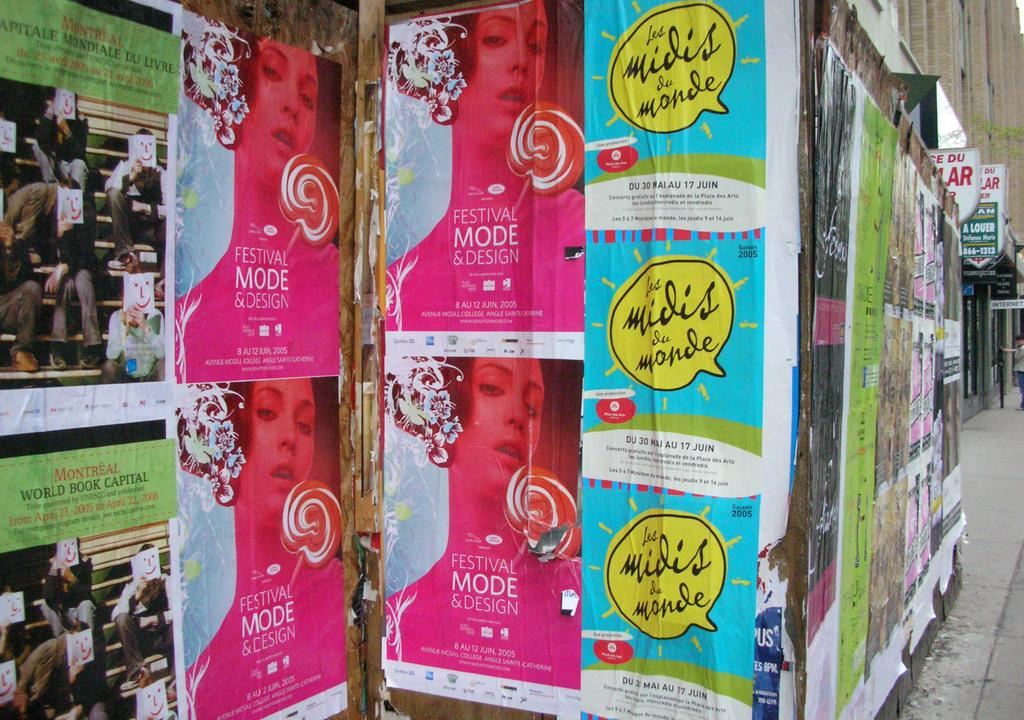<image>
Create a compact narrative representing the image presented. A variety of posters with one group advertising Festival and Mode Design in a pink colored tone. 